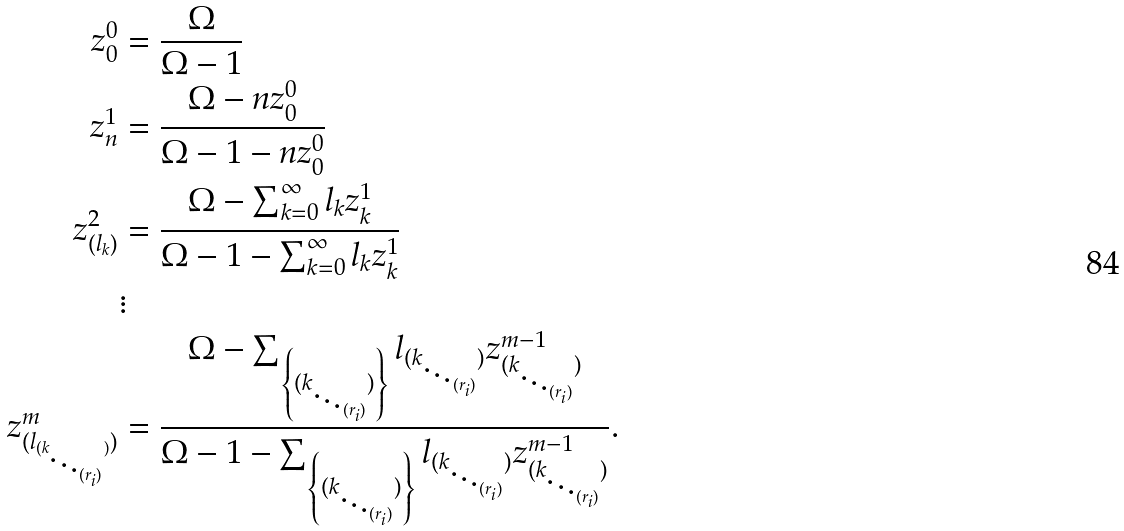Convert formula to latex. <formula><loc_0><loc_0><loc_500><loc_500>z ^ { 0 } _ { 0 } & = \frac { \Omega } { \Omega - 1 } \\ z ^ { 1 } _ { n } & = \frac { \Omega - n z ^ { 0 } _ { 0 } } { \Omega - 1 - n z ^ { 0 } _ { 0 } } \\ z ^ { 2 } _ { ( l _ { k } ) } & = \frac { \Omega - \sum _ { k = 0 } ^ { \infty } l _ { k } z ^ { 1 } _ { k } } { \Omega - 1 - \sum _ { k = 0 } ^ { \infty } l _ { k } z ^ { 1 } _ { k } } \\ & \vdots \\ z ^ { m } _ { ( l _ { ( k _ { \ddots _ { ( r _ { i } ) } } ) } ) } & = \frac { \Omega - \sum _ { \left \{ ( k _ { \ddots _ { ( r _ { i } ) } } ) \right \} } l _ { ( k _ { \ddots _ { ( r _ { i } ) } } ) } z ^ { m - 1 } _ { ( k _ { \ddots _ { ( r _ { i } ) } } ) } } { \Omega - 1 - \sum _ { \left \{ ( k _ { \ddots _ { ( r _ { i } ) } } ) \right \} } l _ { ( k _ { \ddots _ { ( r _ { i } ) } } ) } z ^ { m - 1 } _ { ( k _ { \ddots _ { ( r _ { i } ) } } ) } } .</formula> 